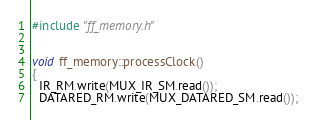<code> <loc_0><loc_0><loc_500><loc_500><_C++_>#include "ff_memory.h"


void ff_memory::processClock()
{
  IR_RM.write(MUX_IR_SM.read());
  DATARED_RM.write(MUX_DATARED_SM.read());</code> 